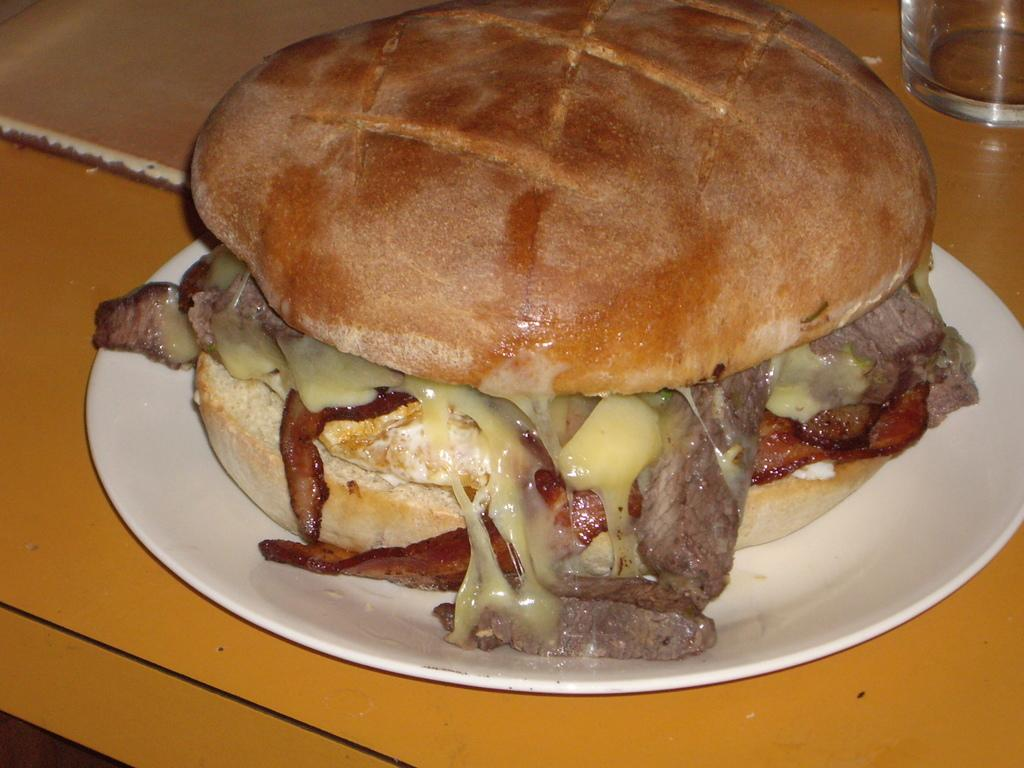What type of food is visible in the image? There is a burger present in the image. Where is the burger located? The burger is in a plate. What other object can be seen on the table in the image? There is a glass on a table in the image. What type of belief is represented by the burger in the image? The image does not represent any beliefs; it simply shows a burger in a plate. Can you see a monkey eating the burger in the image? There is no monkey present in the image. 